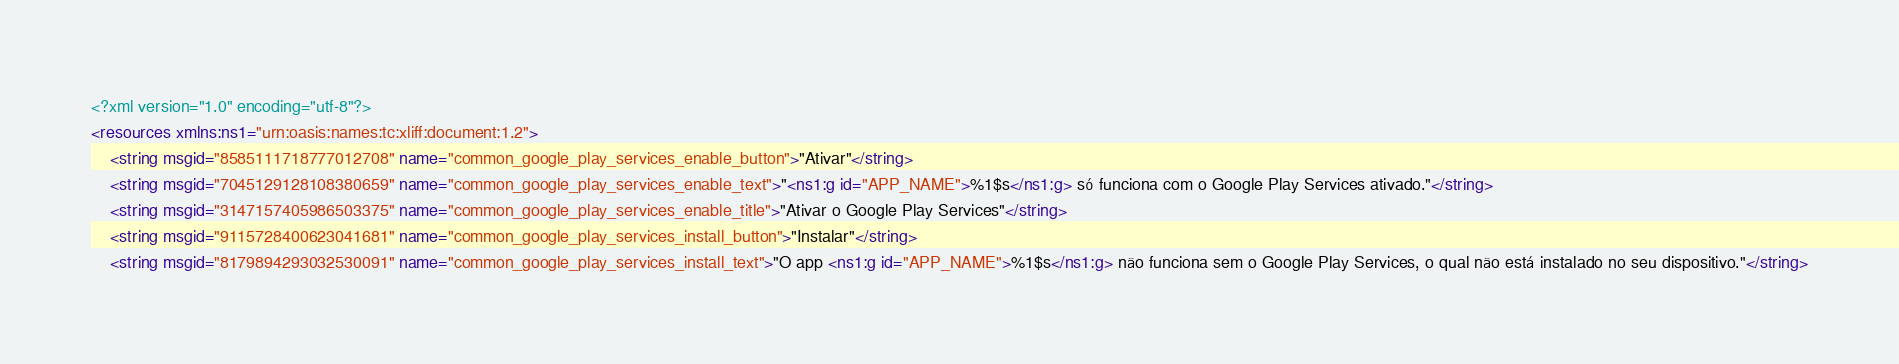<code> <loc_0><loc_0><loc_500><loc_500><_XML_><?xml version="1.0" encoding="utf-8"?>
<resources xmlns:ns1="urn:oasis:names:tc:xliff:document:1.2">
    <string msgid="8585111718777012708" name="common_google_play_services_enable_button">"Ativar"</string>
    <string msgid="7045129128108380659" name="common_google_play_services_enable_text">"<ns1:g id="APP_NAME">%1$s</ns1:g> só funciona com o Google Play Services ativado."</string>
    <string msgid="3147157405986503375" name="common_google_play_services_enable_title">"Ativar o Google Play Services"</string>
    <string msgid="9115728400623041681" name="common_google_play_services_install_button">"Instalar"</string>
    <string msgid="8179894293032530091" name="common_google_play_services_install_text">"O app <ns1:g id="APP_NAME">%1$s</ns1:g> não funciona sem o Google Play Services, o qual não está instalado no seu dispositivo."</string></code> 